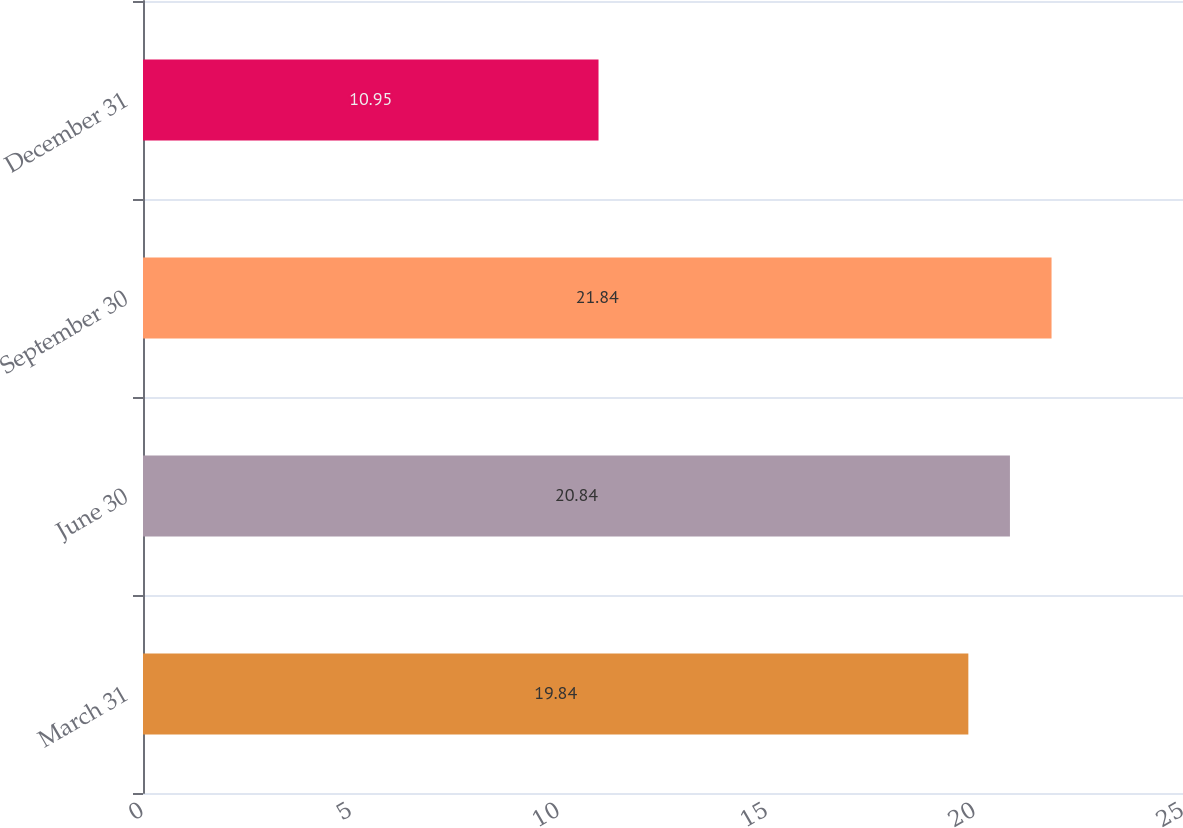Convert chart. <chart><loc_0><loc_0><loc_500><loc_500><bar_chart><fcel>March 31<fcel>June 30<fcel>September 30<fcel>December 31<nl><fcel>19.84<fcel>20.84<fcel>21.84<fcel>10.95<nl></chart> 